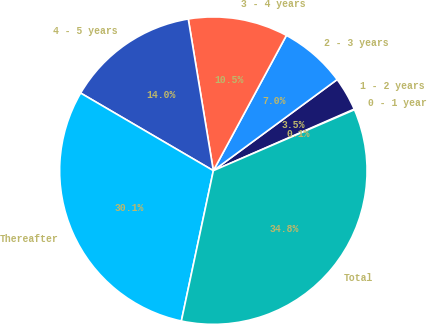Convert chart. <chart><loc_0><loc_0><loc_500><loc_500><pie_chart><fcel>0 - 1 year<fcel>1 - 2 years<fcel>2 - 3 years<fcel>3 - 4 years<fcel>4 - 5 years<fcel>Thereafter<fcel>Total<nl><fcel>0.07%<fcel>3.54%<fcel>7.02%<fcel>10.49%<fcel>13.97%<fcel>30.08%<fcel>34.82%<nl></chart> 